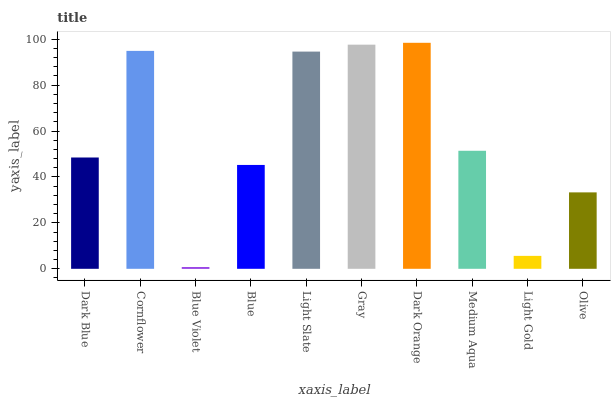Is Cornflower the minimum?
Answer yes or no. No. Is Cornflower the maximum?
Answer yes or no. No. Is Cornflower greater than Dark Blue?
Answer yes or no. Yes. Is Dark Blue less than Cornflower?
Answer yes or no. Yes. Is Dark Blue greater than Cornflower?
Answer yes or no. No. Is Cornflower less than Dark Blue?
Answer yes or no. No. Is Medium Aqua the high median?
Answer yes or no. Yes. Is Dark Blue the low median?
Answer yes or no. Yes. Is Dark Blue the high median?
Answer yes or no. No. Is Blue Violet the low median?
Answer yes or no. No. 